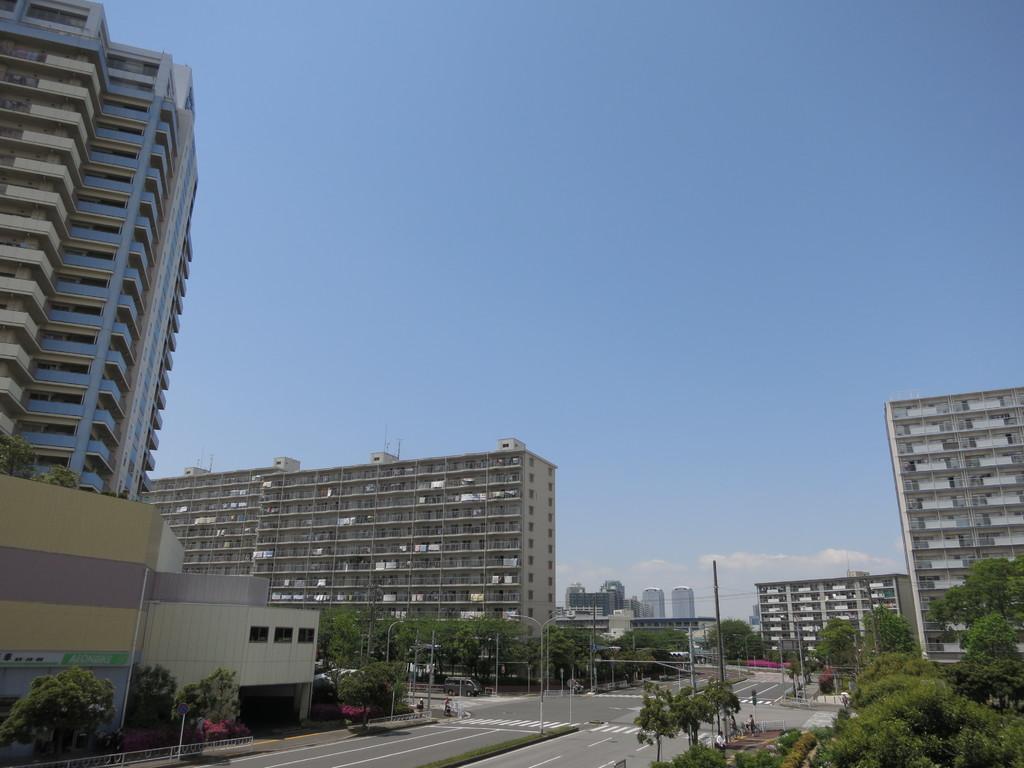Can you describe this image briefly? In this image we can see few buildings, trees, a vehicle on the road, street lights, a pole with wires and the sky in the background. 